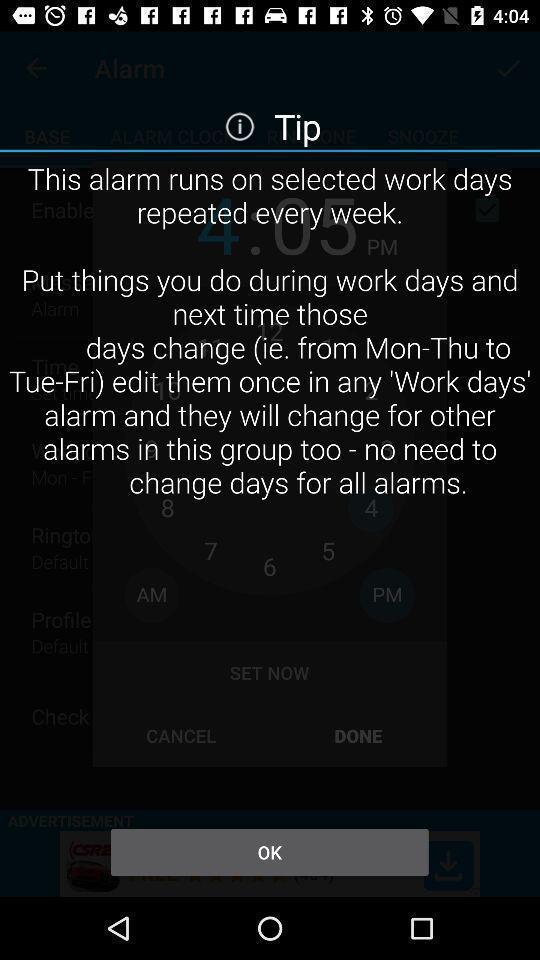Describe the key features of this screenshot. Screen displaying the alarm page with tips. 